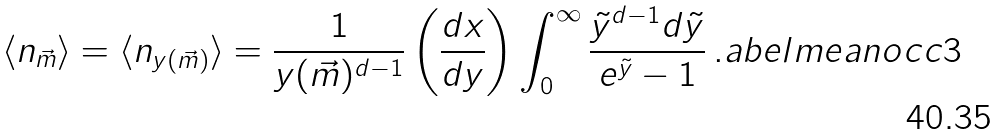Convert formula to latex. <formula><loc_0><loc_0><loc_500><loc_500>\langle n _ { \vec { m } } \rangle = \langle n _ { y ( \vec { m } ) } \rangle = \frac { 1 } { y ( \vec { m } ) ^ { d - 1 } } \left ( \frac { d x } { d y } \right ) \int _ { 0 } ^ { \infty } \frac { \tilde { y } ^ { d - 1 } d \tilde { y } } { e ^ { \tilde { y } } - 1 } \, . \L a b e l { m e a n o c c 3 }</formula> 